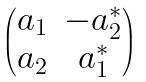<formula> <loc_0><loc_0><loc_500><loc_500>\begin{pmatrix} a _ { 1 } & - a _ { 2 } ^ { * } \\ a _ { 2 } & a _ { 1 } ^ { * } \end{pmatrix}</formula> 